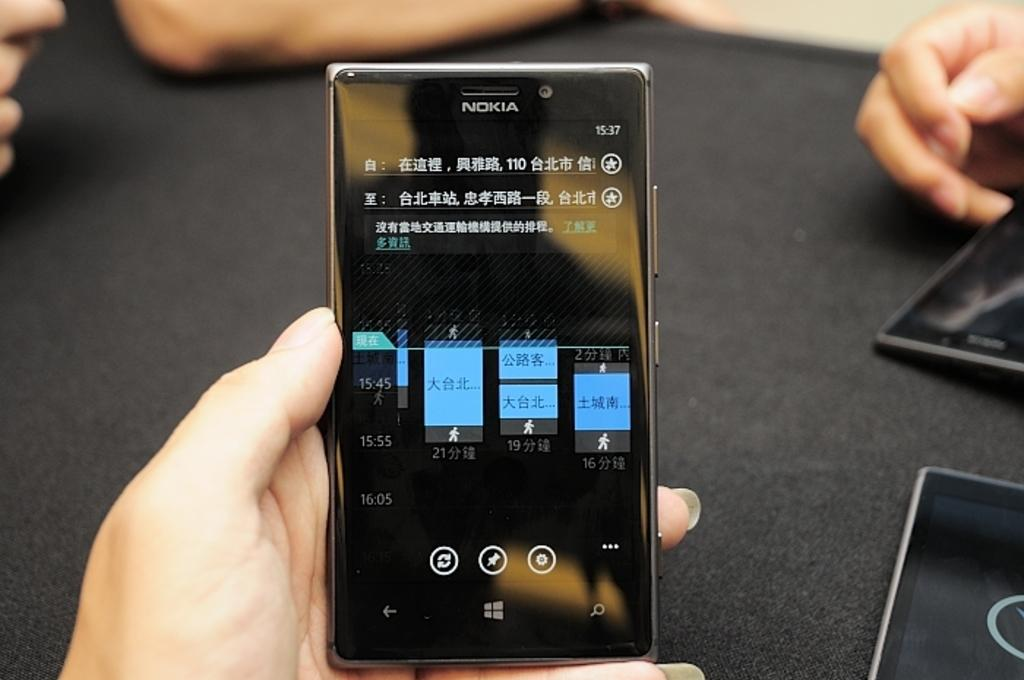<image>
Summarize the visual content of the image. A person is holding a Nokia phone with several lines of foreign letters displayed. 